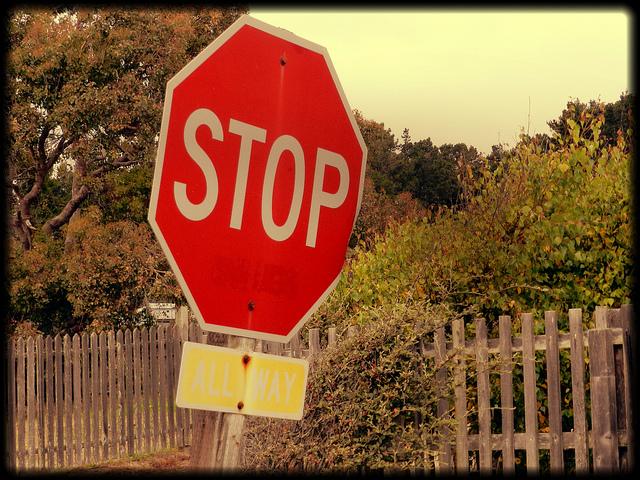What is this fence made of?
Concise answer only. Wood. Is there a fence in the picture?
Write a very short answer. Yes. Would you obey this sign?
Write a very short answer. Yes. 